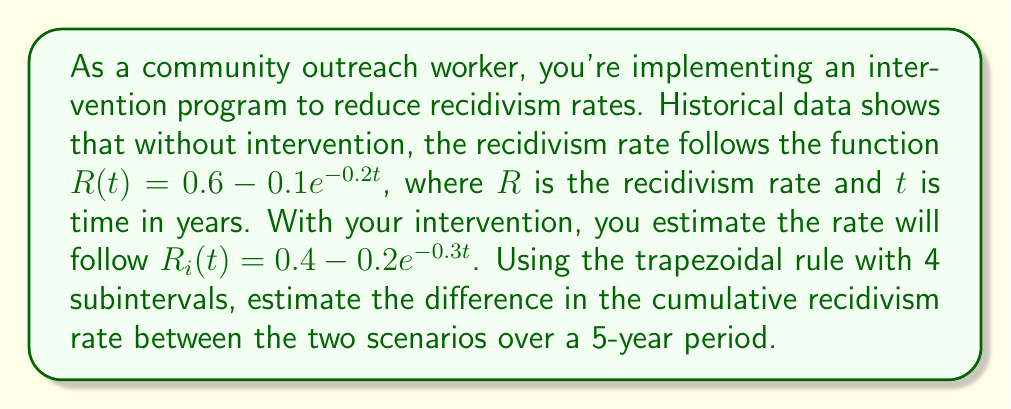Give your solution to this math problem. 1) We need to calculate the definite integral of both functions from 0 to 5 years and find their difference.

2) The trapezoidal rule for 4 subintervals is given by:

   $$\int_a^b f(x)dx \approx \frac{h}{2}[f(x_0) + 2f(x_1) + 2f(x_2) + 2f(x_3) + f(x_4)]$$

   where $h = \frac{b-a}{4}$ and $x_i = a + ih$ for $i = 0, 1, 2, 3, 4$

3) For both functions, $a = 0$, $b = 5$, so $h = \frac{5-0}{4} = 1.25$

4) For $R(t) = 0.6 - 0.1e^{-0.2t}$:
   
   $R(0) = 0.5$
   $R(1.25) = 0.5807$
   $R(2.5) = 0.5951$
   $R(3.75) = 0.5987$
   $R(5) = 0.5996$

   $$\int_0^5 R(t)dt \approx \frac{1.25}{2}[0.5 + 2(0.5807) + 2(0.5951) + 2(0.5987) + 0.5996] = 2.9741$$

5) For $R_i(t) = 0.4 - 0.2e^{-0.3t}$:
   
   $R_i(0) = 0.2$
   $R_i(1.25) = 0.3401$
   $R_i(2.5) = 0.3796$
   $R_i(3.75) = 0.3928$
   $R_i(5) = 0.3975$

   $$\int_0^5 R_i(t)dt \approx \frac{1.25}{2}[0.2 + 2(0.3401) + 2(0.3796) + 2(0.3928) + 0.3975] = 1.8656$$

6) The difference in cumulative recidivism rate:

   $$2.9741 - 1.8656 = 1.1085$$
Answer: 1.1085 